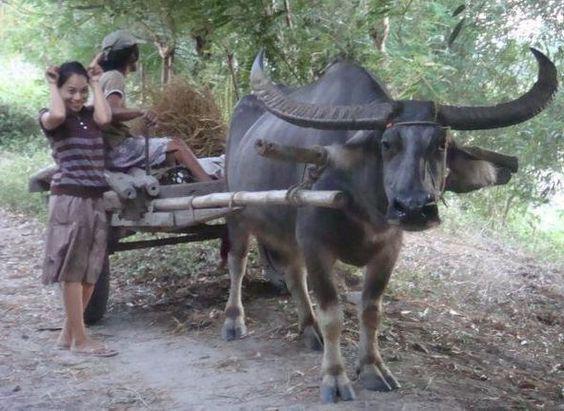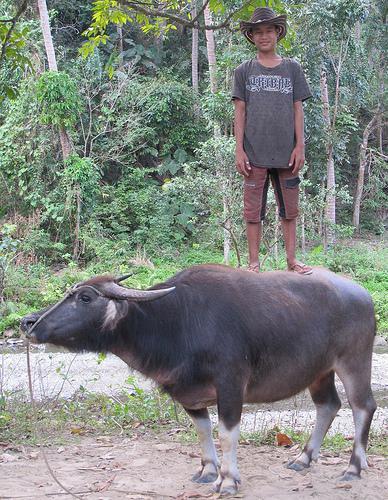The first image is the image on the left, the second image is the image on the right. Assess this claim about the two images: "A man is hitting an animal with a stick.". Correct or not? Answer yes or no. No. The first image is the image on the left, the second image is the image on the right. For the images shown, is this caption "In the left image, a man in a colored head wrap is standing behind two dark oxen and holding out a stick." true? Answer yes or no. No. 